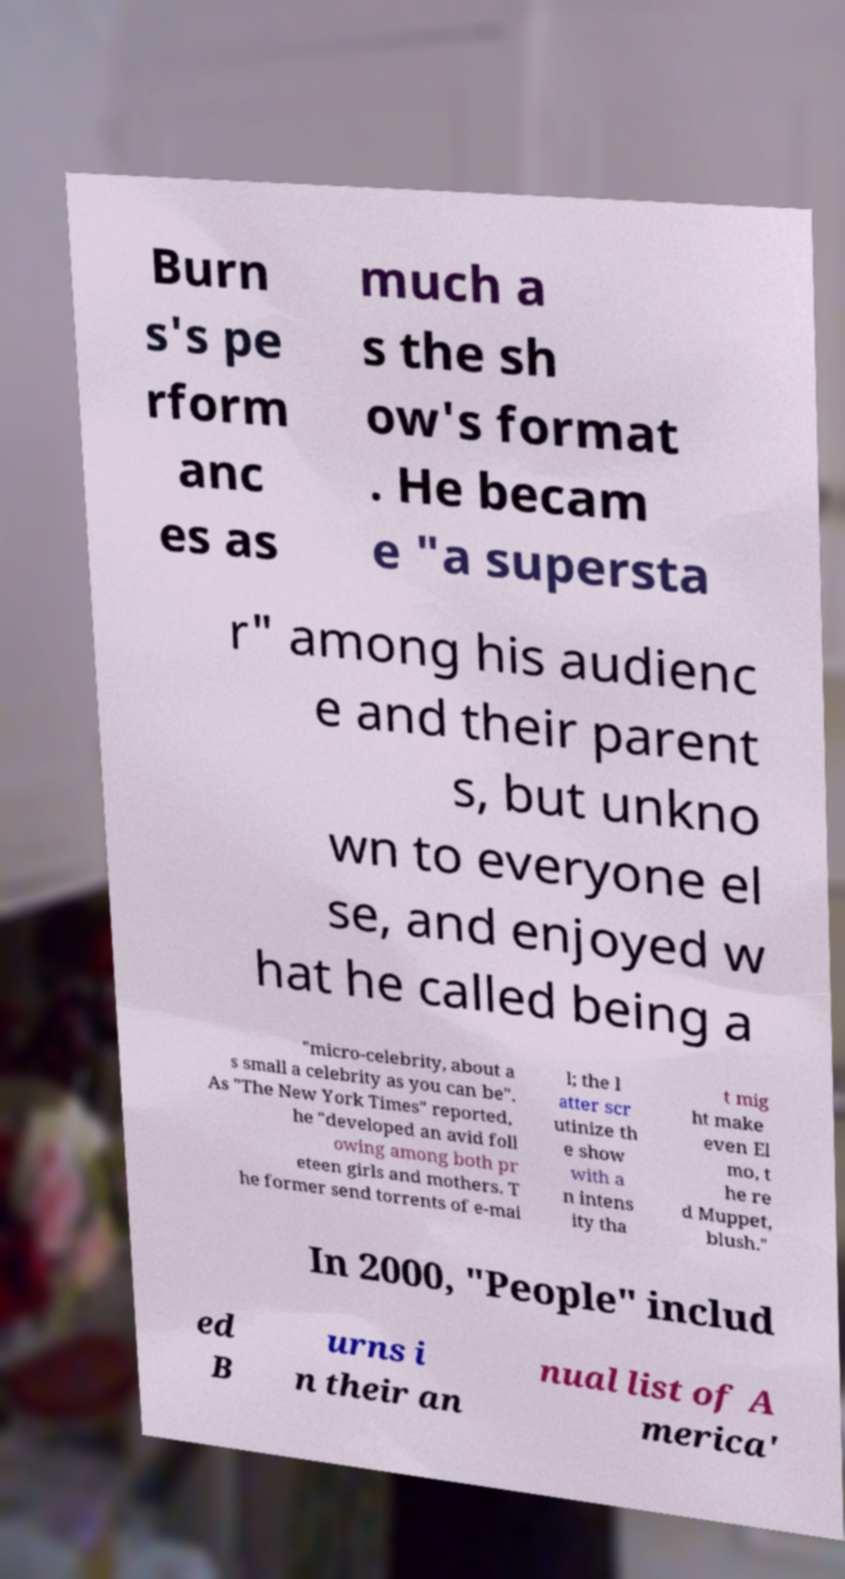What messages or text are displayed in this image? I need them in a readable, typed format. Burn s's pe rform anc es as much a s the sh ow's format . He becam e "a supersta r" among his audienc e and their parent s, but unkno wn to everyone el se, and enjoyed w hat he called being a "micro-celebrity, about a s small a celebrity as you can be". As "The New York Times" reported, he "developed an avid foll owing among both pr eteen girls and mothers. T he former send torrents of e-mai l; the l atter scr utinize th e show with a n intens ity tha t mig ht make even El mo, t he re d Muppet, blush." In 2000, "People" includ ed B urns i n their an nual list of A merica' 